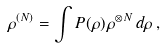Convert formula to latex. <formula><loc_0><loc_0><loc_500><loc_500>\rho ^ { ( N ) } = \int P ( \rho ) \, \rho ^ { \otimes N } \, d \rho \, ,</formula> 